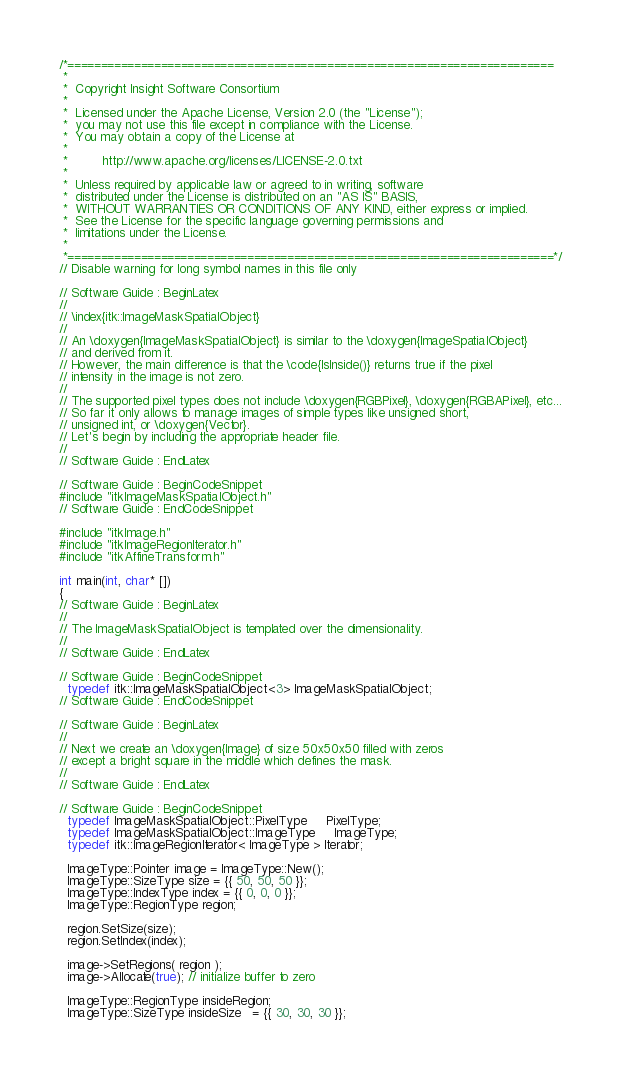<code> <loc_0><loc_0><loc_500><loc_500><_C++_>/*=========================================================================
 *
 *  Copyright Insight Software Consortium
 *
 *  Licensed under the Apache License, Version 2.0 (the "License");
 *  you may not use this file except in compliance with the License.
 *  You may obtain a copy of the License at
 *
 *         http://www.apache.org/licenses/LICENSE-2.0.txt
 *
 *  Unless required by applicable law or agreed to in writing, software
 *  distributed under the License is distributed on an "AS IS" BASIS,
 *  WITHOUT WARRANTIES OR CONDITIONS OF ANY KIND, either express or implied.
 *  See the License for the specific language governing permissions and
 *  limitations under the License.
 *
 *=========================================================================*/
// Disable warning for long symbol names in this file only

// Software Guide : BeginLatex
//
// \index{itk::ImageMaskSpatialObject}
//
// An \doxygen{ImageMaskSpatialObject} is similar to the \doxygen{ImageSpatialObject}
// and derived from it.
// However, the main difference is that the \code{IsInside()} returns true if the pixel
// intensity in the image is not zero.
//
// The supported pixel types does not include \doxygen{RGBPixel}, \doxygen{RGBAPixel}, etc...
// So far it only allows to manage images of simple types like unsigned short,
// unsigned int, or \doxygen{Vector}.
// Let's begin by including the appropriate header file.
//
// Software Guide : EndLatex

// Software Guide : BeginCodeSnippet
#include "itkImageMaskSpatialObject.h"
// Software Guide : EndCodeSnippet

#include "itkImage.h"
#include "itkImageRegionIterator.h"
#include "itkAffineTransform.h"

int main(int, char* [])
{
// Software Guide : BeginLatex
//
// The ImageMaskSpatialObject is templated over the dimensionality.
//
// Software Guide : EndLatex

// Software Guide : BeginCodeSnippet
  typedef itk::ImageMaskSpatialObject<3> ImageMaskSpatialObject;
// Software Guide : EndCodeSnippet

// Software Guide : BeginLatex
//
// Next we create an \doxygen{Image} of size 50x50x50 filled with zeros
// except a bright square in the middle which defines the mask.
//
// Software Guide : EndLatex

// Software Guide : BeginCodeSnippet
  typedef ImageMaskSpatialObject::PixelType     PixelType;
  typedef ImageMaskSpatialObject::ImageType     ImageType;
  typedef itk::ImageRegionIterator< ImageType > Iterator;

  ImageType::Pointer image = ImageType::New();
  ImageType::SizeType size = {{ 50, 50, 50 }};
  ImageType::IndexType index = {{ 0, 0, 0 }};
  ImageType::RegionType region;

  region.SetSize(size);
  region.SetIndex(index);

  image->SetRegions( region );
  image->Allocate(true); // initialize buffer to zero

  ImageType::RegionType insideRegion;
  ImageType::SizeType insideSize   = {{ 30, 30, 30 }};</code> 